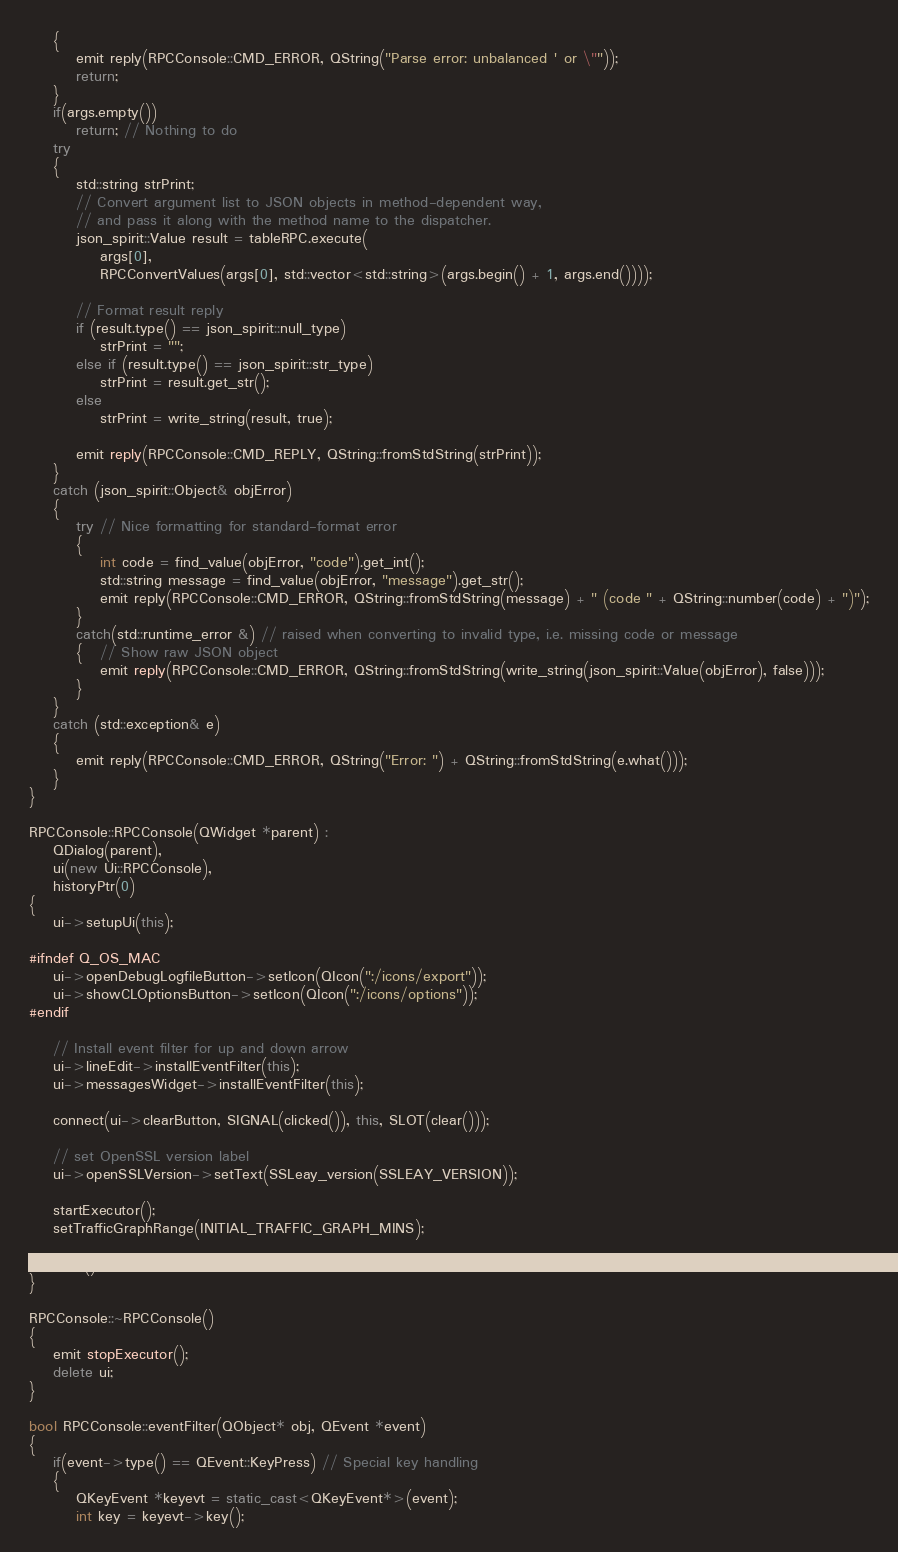Convert code to text. <code><loc_0><loc_0><loc_500><loc_500><_C++_>    {
        emit reply(RPCConsole::CMD_ERROR, QString("Parse error: unbalanced ' or \""));
        return;
    }
    if(args.empty())
        return; // Nothing to do
    try
    {
        std::string strPrint;
        // Convert argument list to JSON objects in method-dependent way,
        // and pass it along with the method name to the dispatcher.
        json_spirit::Value result = tableRPC.execute(
            args[0],
            RPCConvertValues(args[0], std::vector<std::string>(args.begin() + 1, args.end())));

        // Format result reply
        if (result.type() == json_spirit::null_type)
            strPrint = "";
        else if (result.type() == json_spirit::str_type)
            strPrint = result.get_str();
        else
            strPrint = write_string(result, true);

        emit reply(RPCConsole::CMD_REPLY, QString::fromStdString(strPrint));
    }
    catch (json_spirit::Object& objError)
    {
        try // Nice formatting for standard-format error
        {
            int code = find_value(objError, "code").get_int();
            std::string message = find_value(objError, "message").get_str();
            emit reply(RPCConsole::CMD_ERROR, QString::fromStdString(message) + " (code " + QString::number(code) + ")");
        }
        catch(std::runtime_error &) // raised when converting to invalid type, i.e. missing code or message
        {   // Show raw JSON object
            emit reply(RPCConsole::CMD_ERROR, QString::fromStdString(write_string(json_spirit::Value(objError), false)));
        }
    }
    catch (std::exception& e)
    {
        emit reply(RPCConsole::CMD_ERROR, QString("Error: ") + QString::fromStdString(e.what()));
    }
}

RPCConsole::RPCConsole(QWidget *parent) :
    QDialog(parent),
    ui(new Ui::RPCConsole),
    historyPtr(0)
{
    ui->setupUi(this);

#ifndef Q_OS_MAC
    ui->openDebugLogfileButton->setIcon(QIcon(":/icons/export"));
    ui->showCLOptionsButton->setIcon(QIcon(":/icons/options"));
#endif

    // Install event filter for up and down arrow
    ui->lineEdit->installEventFilter(this);
    ui->messagesWidget->installEventFilter(this);

    connect(ui->clearButton, SIGNAL(clicked()), this, SLOT(clear()));

    // set OpenSSL version label
    ui->openSSLVersion->setText(SSLeay_version(SSLEAY_VERSION));

    startExecutor();
    setTrafficGraphRange(INITIAL_TRAFFIC_GRAPH_MINS);

    clear();
}

RPCConsole::~RPCConsole()
{
    emit stopExecutor();
    delete ui;
}

bool RPCConsole::eventFilter(QObject* obj, QEvent *event)
{
    if(event->type() == QEvent::KeyPress) // Special key handling
    {
        QKeyEvent *keyevt = static_cast<QKeyEvent*>(event);
        int key = keyevt->key();</code> 